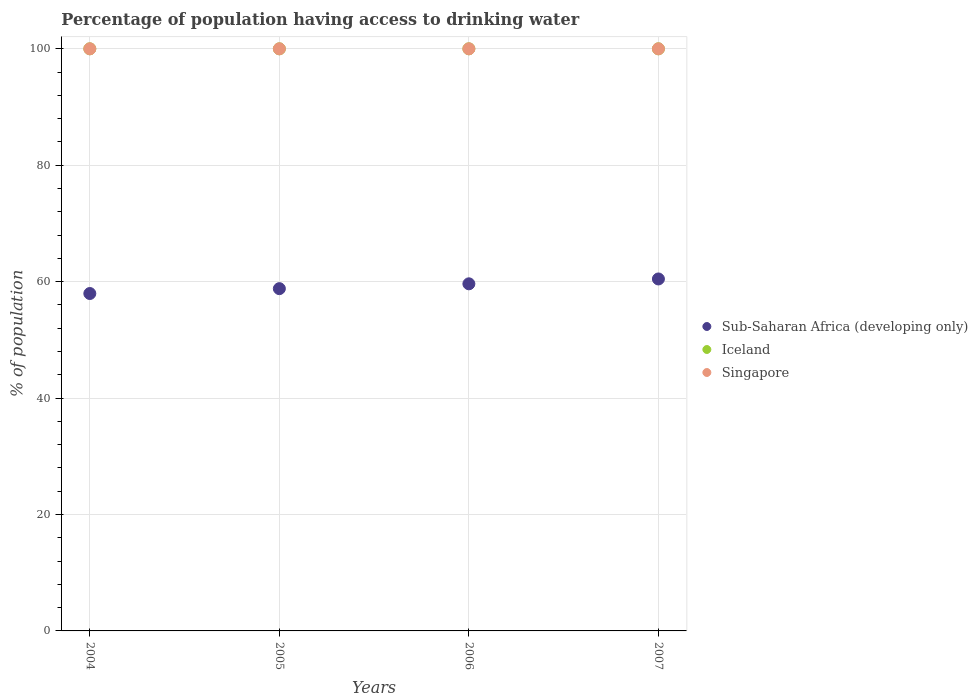How many different coloured dotlines are there?
Make the answer very short. 3. What is the percentage of population having access to drinking water in Iceland in 2007?
Ensure brevity in your answer.  100. Across all years, what is the maximum percentage of population having access to drinking water in Iceland?
Your response must be concise. 100. Across all years, what is the minimum percentage of population having access to drinking water in Sub-Saharan Africa (developing only)?
Keep it short and to the point. 57.96. In which year was the percentage of population having access to drinking water in Iceland maximum?
Make the answer very short. 2004. What is the total percentage of population having access to drinking water in Singapore in the graph?
Make the answer very short. 400. What is the difference between the percentage of population having access to drinking water in Sub-Saharan Africa (developing only) in 2004 and that in 2005?
Provide a succinct answer. -0.84. What is the difference between the percentage of population having access to drinking water in Sub-Saharan Africa (developing only) in 2004 and the percentage of population having access to drinking water in Singapore in 2005?
Give a very brief answer. -42.04. In the year 2004, what is the difference between the percentage of population having access to drinking water in Singapore and percentage of population having access to drinking water in Sub-Saharan Africa (developing only)?
Provide a succinct answer. 42.04. In how many years, is the percentage of population having access to drinking water in Singapore greater than 64 %?
Give a very brief answer. 4. What is the ratio of the percentage of population having access to drinking water in Sub-Saharan Africa (developing only) in 2005 to that in 2007?
Provide a succinct answer. 0.97. Is it the case that in every year, the sum of the percentage of population having access to drinking water in Sub-Saharan Africa (developing only) and percentage of population having access to drinking water in Iceland  is greater than the percentage of population having access to drinking water in Singapore?
Offer a very short reply. Yes. Does the percentage of population having access to drinking water in Singapore monotonically increase over the years?
Keep it short and to the point. No. Is the percentage of population having access to drinking water in Iceland strictly greater than the percentage of population having access to drinking water in Singapore over the years?
Give a very brief answer. No. Is the percentage of population having access to drinking water in Iceland strictly less than the percentage of population having access to drinking water in Sub-Saharan Africa (developing only) over the years?
Keep it short and to the point. No. How many years are there in the graph?
Offer a terse response. 4. What is the difference between two consecutive major ticks on the Y-axis?
Provide a succinct answer. 20. Are the values on the major ticks of Y-axis written in scientific E-notation?
Your response must be concise. No. Does the graph contain grids?
Give a very brief answer. Yes. How are the legend labels stacked?
Ensure brevity in your answer.  Vertical. What is the title of the graph?
Provide a succinct answer. Percentage of population having access to drinking water. Does "Chad" appear as one of the legend labels in the graph?
Offer a very short reply. No. What is the label or title of the X-axis?
Your response must be concise. Years. What is the label or title of the Y-axis?
Ensure brevity in your answer.  % of population. What is the % of population in Sub-Saharan Africa (developing only) in 2004?
Your answer should be very brief. 57.96. What is the % of population of Singapore in 2004?
Your answer should be very brief. 100. What is the % of population in Sub-Saharan Africa (developing only) in 2005?
Your response must be concise. 58.8. What is the % of population of Iceland in 2005?
Offer a very short reply. 100. What is the % of population in Singapore in 2005?
Your answer should be very brief. 100. What is the % of population of Sub-Saharan Africa (developing only) in 2006?
Provide a succinct answer. 59.63. What is the % of population in Iceland in 2006?
Your response must be concise. 100. What is the % of population in Sub-Saharan Africa (developing only) in 2007?
Offer a very short reply. 60.46. Across all years, what is the maximum % of population in Sub-Saharan Africa (developing only)?
Make the answer very short. 60.46. Across all years, what is the maximum % of population in Singapore?
Offer a terse response. 100. Across all years, what is the minimum % of population in Sub-Saharan Africa (developing only)?
Make the answer very short. 57.96. Across all years, what is the minimum % of population of Iceland?
Your answer should be compact. 100. Across all years, what is the minimum % of population of Singapore?
Make the answer very short. 100. What is the total % of population of Sub-Saharan Africa (developing only) in the graph?
Make the answer very short. 236.85. What is the difference between the % of population in Sub-Saharan Africa (developing only) in 2004 and that in 2005?
Offer a terse response. -0.84. What is the difference between the % of population in Iceland in 2004 and that in 2005?
Your answer should be very brief. 0. What is the difference between the % of population of Singapore in 2004 and that in 2005?
Offer a terse response. 0. What is the difference between the % of population of Sub-Saharan Africa (developing only) in 2004 and that in 2006?
Provide a succinct answer. -1.67. What is the difference between the % of population of Singapore in 2004 and that in 2006?
Offer a terse response. 0. What is the difference between the % of population in Sub-Saharan Africa (developing only) in 2004 and that in 2007?
Make the answer very short. -2.5. What is the difference between the % of population in Sub-Saharan Africa (developing only) in 2005 and that in 2006?
Provide a succinct answer. -0.83. What is the difference between the % of population of Iceland in 2005 and that in 2006?
Offer a very short reply. 0. What is the difference between the % of population in Singapore in 2005 and that in 2006?
Your response must be concise. 0. What is the difference between the % of population of Sub-Saharan Africa (developing only) in 2005 and that in 2007?
Your answer should be very brief. -1.66. What is the difference between the % of population of Iceland in 2005 and that in 2007?
Provide a short and direct response. 0. What is the difference between the % of population in Sub-Saharan Africa (developing only) in 2006 and that in 2007?
Make the answer very short. -0.83. What is the difference between the % of population of Iceland in 2006 and that in 2007?
Keep it short and to the point. 0. What is the difference between the % of population in Singapore in 2006 and that in 2007?
Ensure brevity in your answer.  0. What is the difference between the % of population in Sub-Saharan Africa (developing only) in 2004 and the % of population in Iceland in 2005?
Ensure brevity in your answer.  -42.04. What is the difference between the % of population of Sub-Saharan Africa (developing only) in 2004 and the % of population of Singapore in 2005?
Provide a succinct answer. -42.04. What is the difference between the % of population in Iceland in 2004 and the % of population in Singapore in 2005?
Provide a short and direct response. 0. What is the difference between the % of population of Sub-Saharan Africa (developing only) in 2004 and the % of population of Iceland in 2006?
Provide a short and direct response. -42.04. What is the difference between the % of population in Sub-Saharan Africa (developing only) in 2004 and the % of population in Singapore in 2006?
Provide a succinct answer. -42.04. What is the difference between the % of population in Iceland in 2004 and the % of population in Singapore in 2006?
Make the answer very short. 0. What is the difference between the % of population in Sub-Saharan Africa (developing only) in 2004 and the % of population in Iceland in 2007?
Your answer should be compact. -42.04. What is the difference between the % of population in Sub-Saharan Africa (developing only) in 2004 and the % of population in Singapore in 2007?
Offer a terse response. -42.04. What is the difference between the % of population of Iceland in 2004 and the % of population of Singapore in 2007?
Keep it short and to the point. 0. What is the difference between the % of population in Sub-Saharan Africa (developing only) in 2005 and the % of population in Iceland in 2006?
Your response must be concise. -41.2. What is the difference between the % of population in Sub-Saharan Africa (developing only) in 2005 and the % of population in Singapore in 2006?
Your answer should be very brief. -41.2. What is the difference between the % of population of Sub-Saharan Africa (developing only) in 2005 and the % of population of Iceland in 2007?
Your answer should be very brief. -41.2. What is the difference between the % of population of Sub-Saharan Africa (developing only) in 2005 and the % of population of Singapore in 2007?
Offer a very short reply. -41.2. What is the difference between the % of population in Iceland in 2005 and the % of population in Singapore in 2007?
Offer a very short reply. 0. What is the difference between the % of population of Sub-Saharan Africa (developing only) in 2006 and the % of population of Iceland in 2007?
Your answer should be compact. -40.37. What is the difference between the % of population in Sub-Saharan Africa (developing only) in 2006 and the % of population in Singapore in 2007?
Make the answer very short. -40.37. What is the difference between the % of population of Iceland in 2006 and the % of population of Singapore in 2007?
Your answer should be compact. 0. What is the average % of population of Sub-Saharan Africa (developing only) per year?
Make the answer very short. 59.21. In the year 2004, what is the difference between the % of population of Sub-Saharan Africa (developing only) and % of population of Iceland?
Provide a succinct answer. -42.04. In the year 2004, what is the difference between the % of population of Sub-Saharan Africa (developing only) and % of population of Singapore?
Offer a very short reply. -42.04. In the year 2005, what is the difference between the % of population in Sub-Saharan Africa (developing only) and % of population in Iceland?
Provide a succinct answer. -41.2. In the year 2005, what is the difference between the % of population of Sub-Saharan Africa (developing only) and % of population of Singapore?
Make the answer very short. -41.2. In the year 2005, what is the difference between the % of population in Iceland and % of population in Singapore?
Give a very brief answer. 0. In the year 2006, what is the difference between the % of population of Sub-Saharan Africa (developing only) and % of population of Iceland?
Provide a short and direct response. -40.37. In the year 2006, what is the difference between the % of population in Sub-Saharan Africa (developing only) and % of population in Singapore?
Offer a terse response. -40.37. In the year 2007, what is the difference between the % of population in Sub-Saharan Africa (developing only) and % of population in Iceland?
Provide a short and direct response. -39.54. In the year 2007, what is the difference between the % of population in Sub-Saharan Africa (developing only) and % of population in Singapore?
Offer a terse response. -39.54. What is the ratio of the % of population in Sub-Saharan Africa (developing only) in 2004 to that in 2005?
Give a very brief answer. 0.99. What is the ratio of the % of population in Singapore in 2004 to that in 2005?
Keep it short and to the point. 1. What is the ratio of the % of population in Sub-Saharan Africa (developing only) in 2004 to that in 2006?
Provide a succinct answer. 0.97. What is the ratio of the % of population of Iceland in 2004 to that in 2006?
Give a very brief answer. 1. What is the ratio of the % of population of Singapore in 2004 to that in 2006?
Offer a terse response. 1. What is the ratio of the % of population in Sub-Saharan Africa (developing only) in 2004 to that in 2007?
Provide a succinct answer. 0.96. What is the ratio of the % of population in Singapore in 2004 to that in 2007?
Offer a very short reply. 1. What is the ratio of the % of population in Sub-Saharan Africa (developing only) in 2005 to that in 2006?
Your response must be concise. 0.99. What is the ratio of the % of population of Iceland in 2005 to that in 2006?
Provide a short and direct response. 1. What is the ratio of the % of population in Sub-Saharan Africa (developing only) in 2005 to that in 2007?
Your answer should be compact. 0.97. What is the ratio of the % of population of Singapore in 2005 to that in 2007?
Give a very brief answer. 1. What is the ratio of the % of population in Sub-Saharan Africa (developing only) in 2006 to that in 2007?
Ensure brevity in your answer.  0.99. What is the difference between the highest and the second highest % of population of Sub-Saharan Africa (developing only)?
Your response must be concise. 0.83. What is the difference between the highest and the second highest % of population of Iceland?
Provide a short and direct response. 0. What is the difference between the highest and the lowest % of population in Sub-Saharan Africa (developing only)?
Provide a succinct answer. 2.5. What is the difference between the highest and the lowest % of population in Iceland?
Give a very brief answer. 0. 